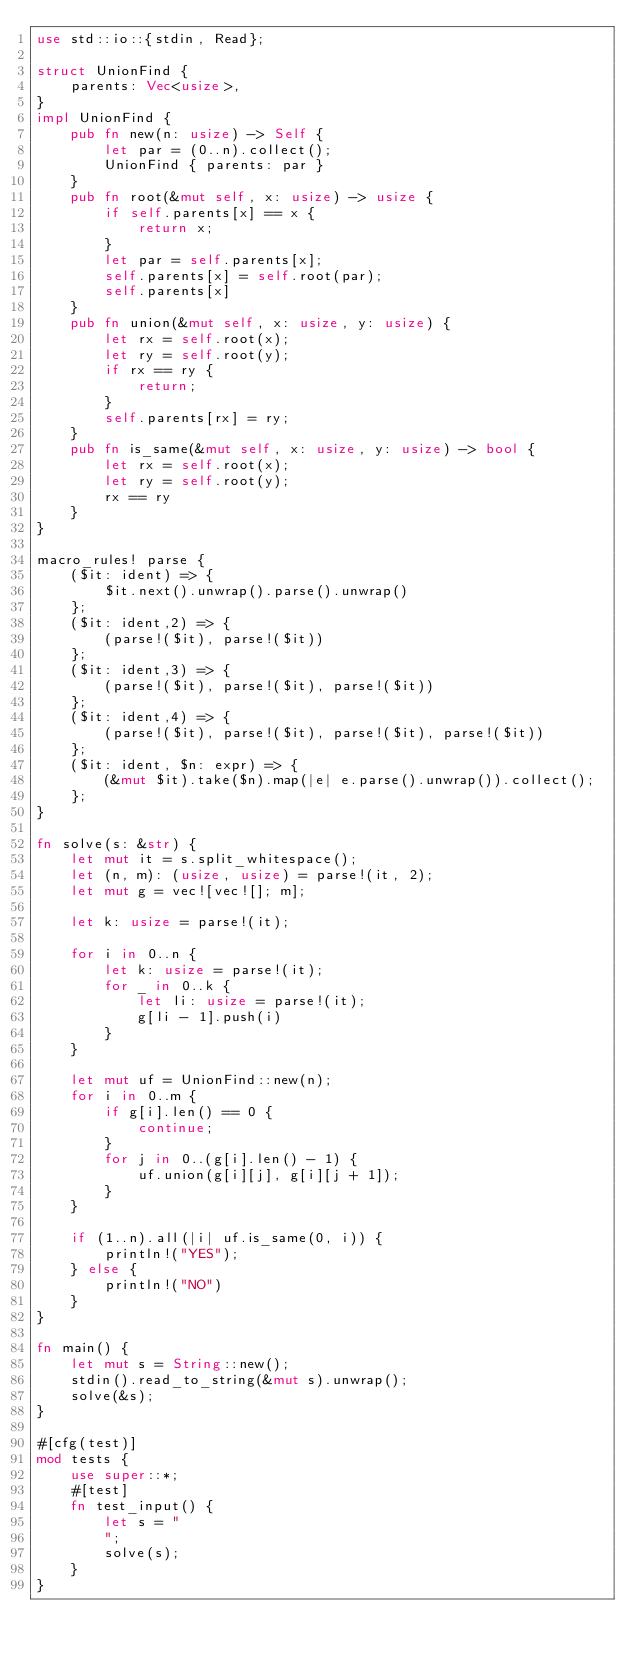<code> <loc_0><loc_0><loc_500><loc_500><_Rust_>use std::io::{stdin, Read};

struct UnionFind {
    parents: Vec<usize>,
}
impl UnionFind {
    pub fn new(n: usize) -> Self {
        let par = (0..n).collect();
        UnionFind { parents: par }
    }
    pub fn root(&mut self, x: usize) -> usize {
        if self.parents[x] == x {
            return x;
        }
        let par = self.parents[x];
        self.parents[x] = self.root(par);
        self.parents[x]
    }
    pub fn union(&mut self, x: usize, y: usize) {
        let rx = self.root(x);
        let ry = self.root(y);
        if rx == ry {
            return;
        }
        self.parents[rx] = ry;
    }
    pub fn is_same(&mut self, x: usize, y: usize) -> bool {
        let rx = self.root(x);
        let ry = self.root(y);
        rx == ry
    }
}

macro_rules! parse {
    ($it: ident) => {
        $it.next().unwrap().parse().unwrap()
    };
    ($it: ident,2) => {
        (parse!($it), parse!($it))
    };
    ($it: ident,3) => {
        (parse!($it), parse!($it), parse!($it))
    };
    ($it: ident,4) => {
        (parse!($it), parse!($it), parse!($it), parse!($it))
    };
    ($it: ident, $n: expr) => {
        (&mut $it).take($n).map(|e| e.parse().unwrap()).collect();
    };
}

fn solve(s: &str) {
    let mut it = s.split_whitespace();
    let (n, m): (usize, usize) = parse!(it, 2);
    let mut g = vec![vec![]; m];

    let k: usize = parse!(it);

    for i in 0..n {
        let k: usize = parse!(it);
        for _ in 0..k {
            let li: usize = parse!(it);
            g[li - 1].push(i)
        }
    }

    let mut uf = UnionFind::new(n);
    for i in 0..m {
        if g[i].len() == 0 {
            continue;
        }
        for j in 0..(g[i].len() - 1) {
            uf.union(g[i][j], g[i][j + 1]);
        }
    }

    if (1..n).all(|i| uf.is_same(0, i)) {
        println!("YES");
    } else {
        println!("NO")
    }
}

fn main() {
    let mut s = String::new();
    stdin().read_to_string(&mut s).unwrap();
    solve(&s);
}

#[cfg(test)]
mod tests {
    use super::*;
    #[test]
    fn test_input() {
        let s = "
        ";
        solve(s);
    }
}
</code> 